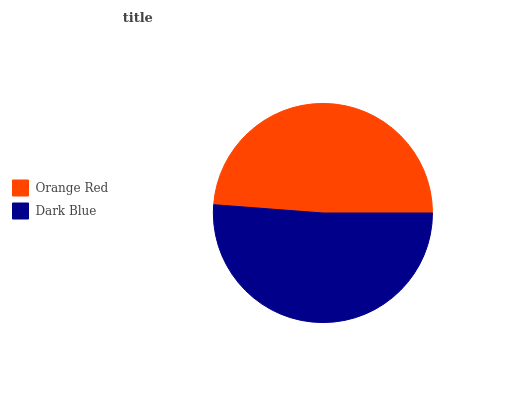Is Orange Red the minimum?
Answer yes or no. Yes. Is Dark Blue the maximum?
Answer yes or no. Yes. Is Dark Blue the minimum?
Answer yes or no. No. Is Dark Blue greater than Orange Red?
Answer yes or no. Yes. Is Orange Red less than Dark Blue?
Answer yes or no. Yes. Is Orange Red greater than Dark Blue?
Answer yes or no. No. Is Dark Blue less than Orange Red?
Answer yes or no. No. Is Dark Blue the high median?
Answer yes or no. Yes. Is Orange Red the low median?
Answer yes or no. Yes. Is Orange Red the high median?
Answer yes or no. No. Is Dark Blue the low median?
Answer yes or no. No. 